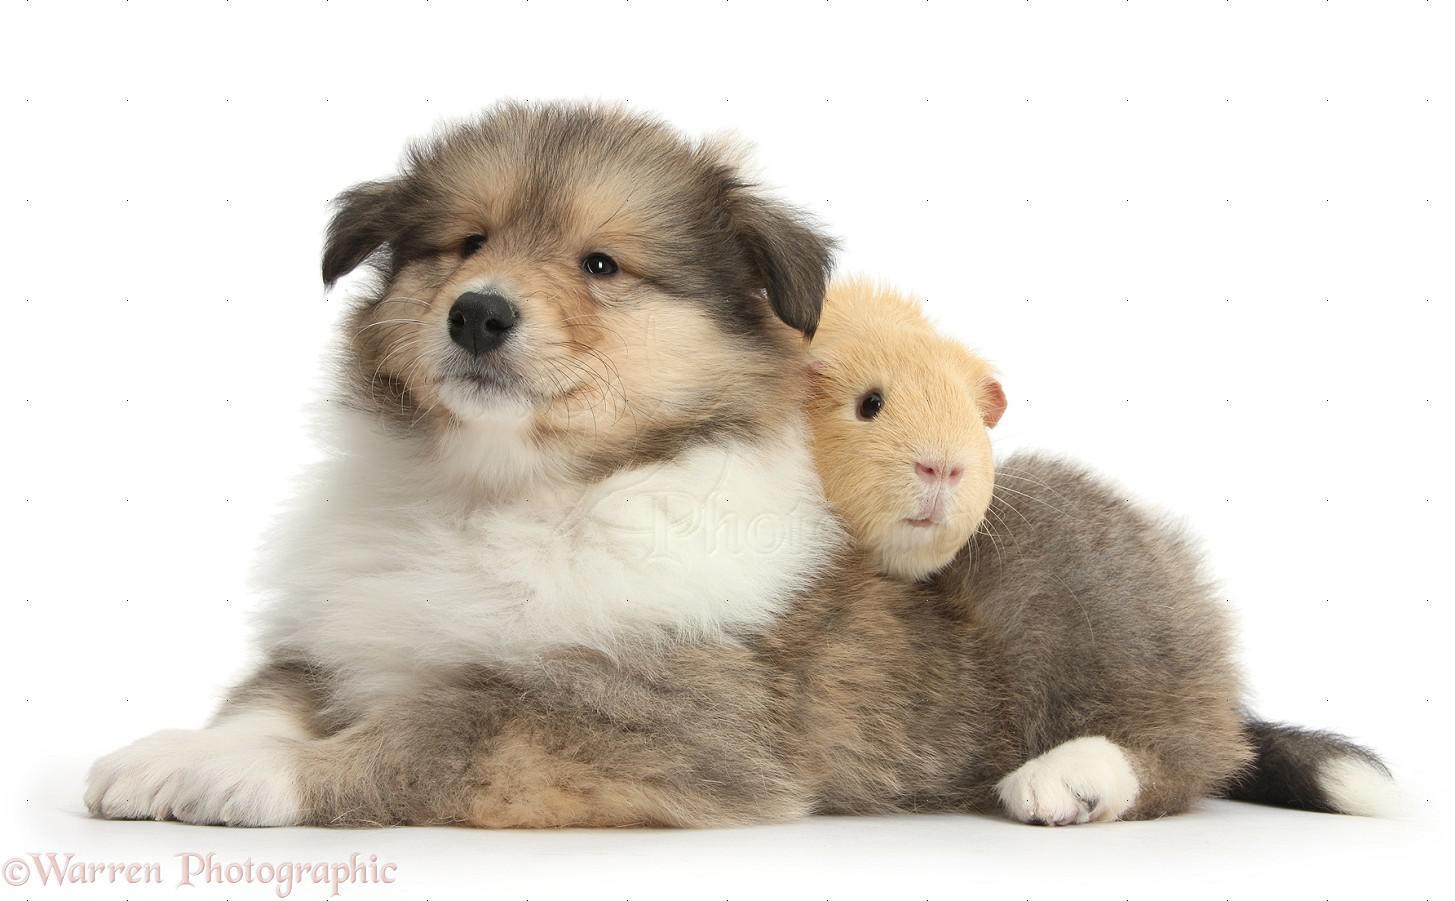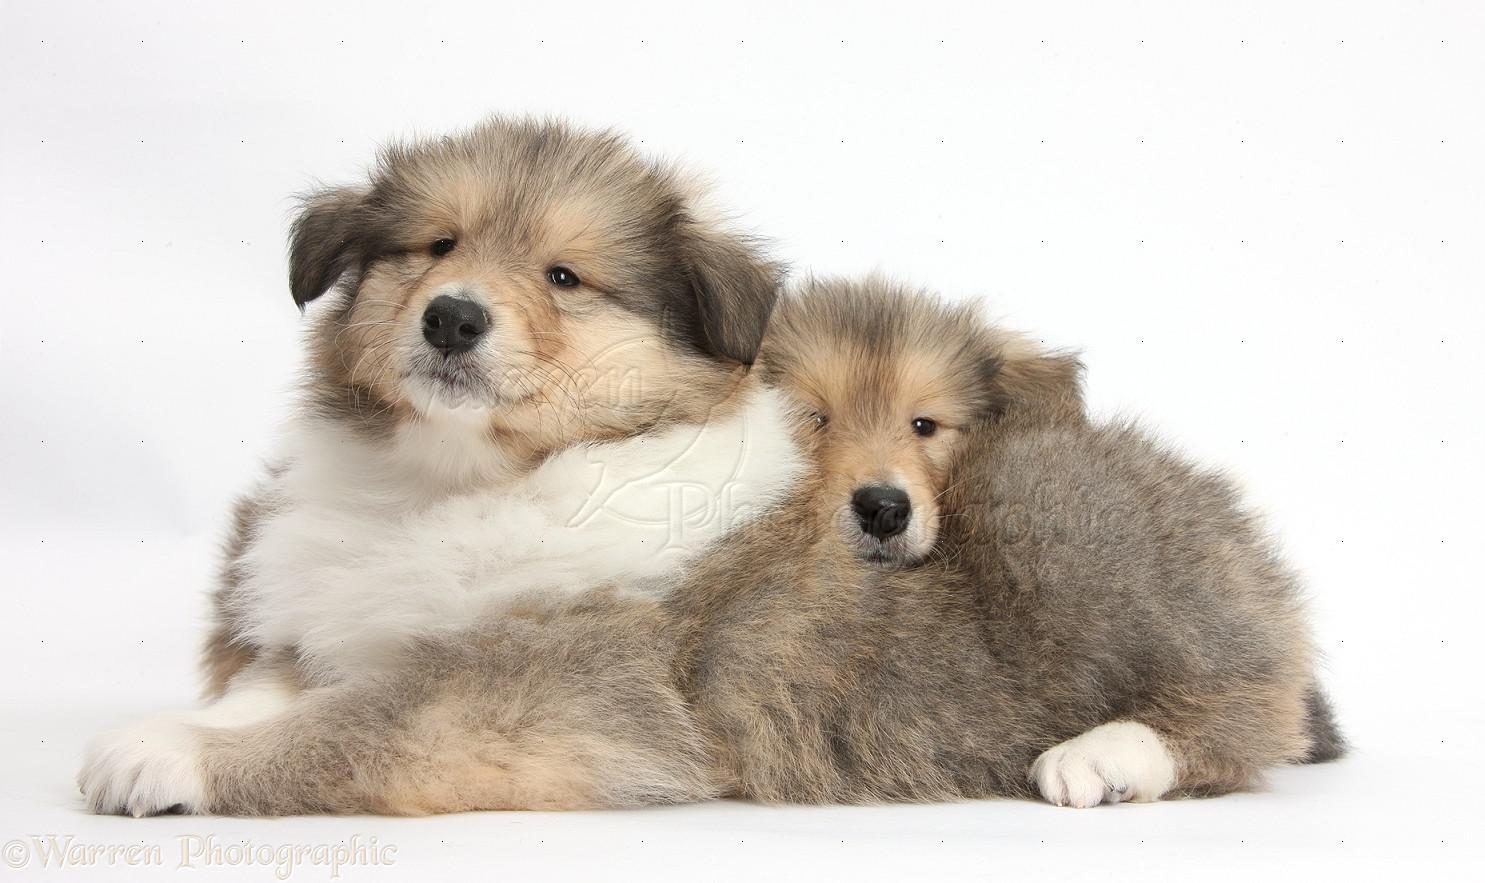The first image is the image on the left, the second image is the image on the right. Analyze the images presented: Is the assertion "Left and right images contain a collie pup that looks the other's twin, and the combined images show at least three of these look-alike pups." valid? Answer yes or no. Yes. 